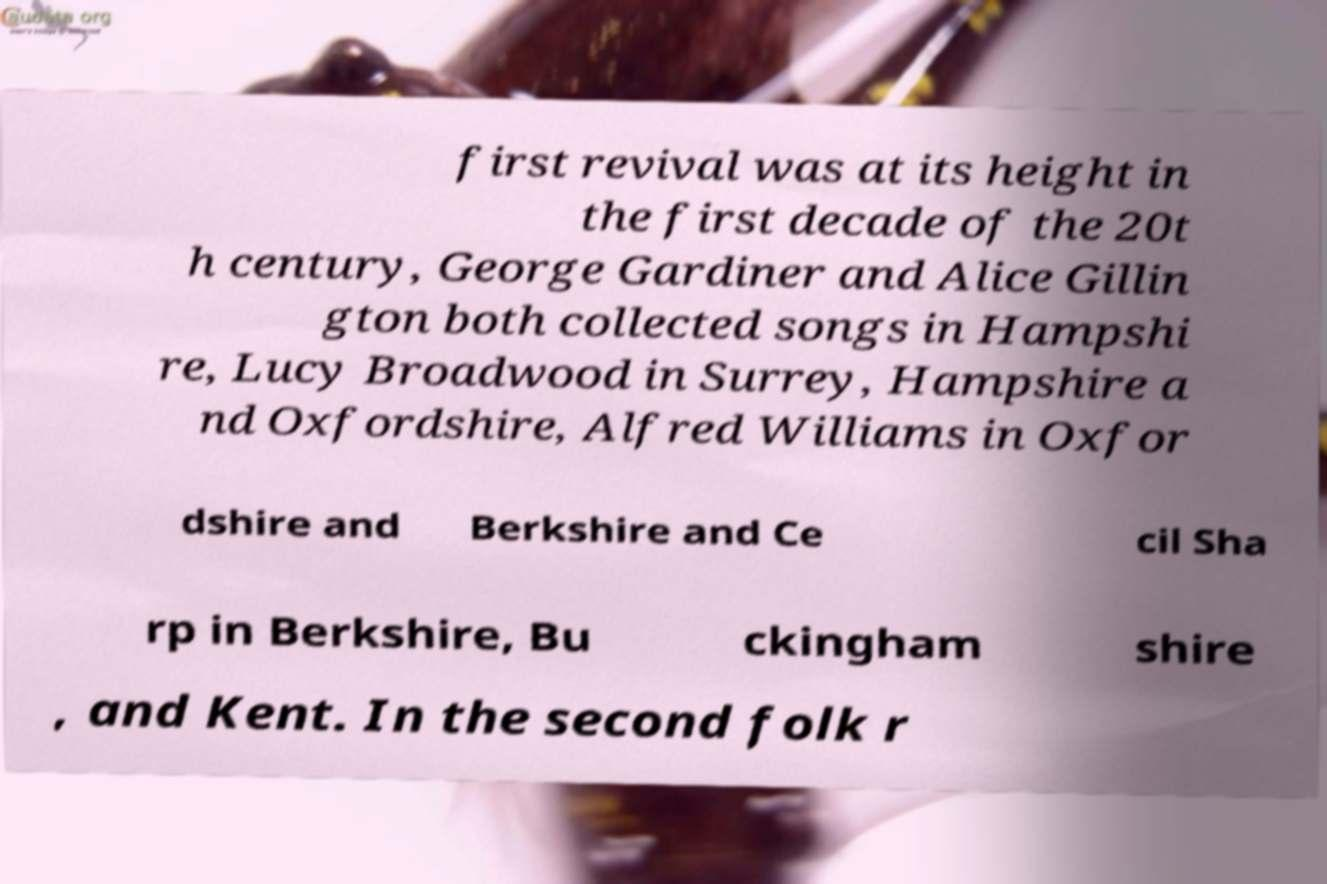I need the written content from this picture converted into text. Can you do that? first revival was at its height in the first decade of the 20t h century, George Gardiner and Alice Gillin gton both collected songs in Hampshi re, Lucy Broadwood in Surrey, Hampshire a nd Oxfordshire, Alfred Williams in Oxfor dshire and Berkshire and Ce cil Sha rp in Berkshire, Bu ckingham shire , and Kent. In the second folk r 